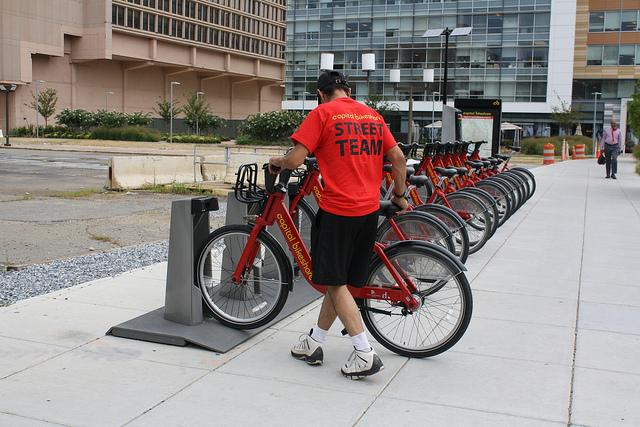What is the man standing next to the bikes most likely doing? Please explain your reasoning. working. He is wearing a branded t shirt which is the same branding as that on the side of the bikes. 